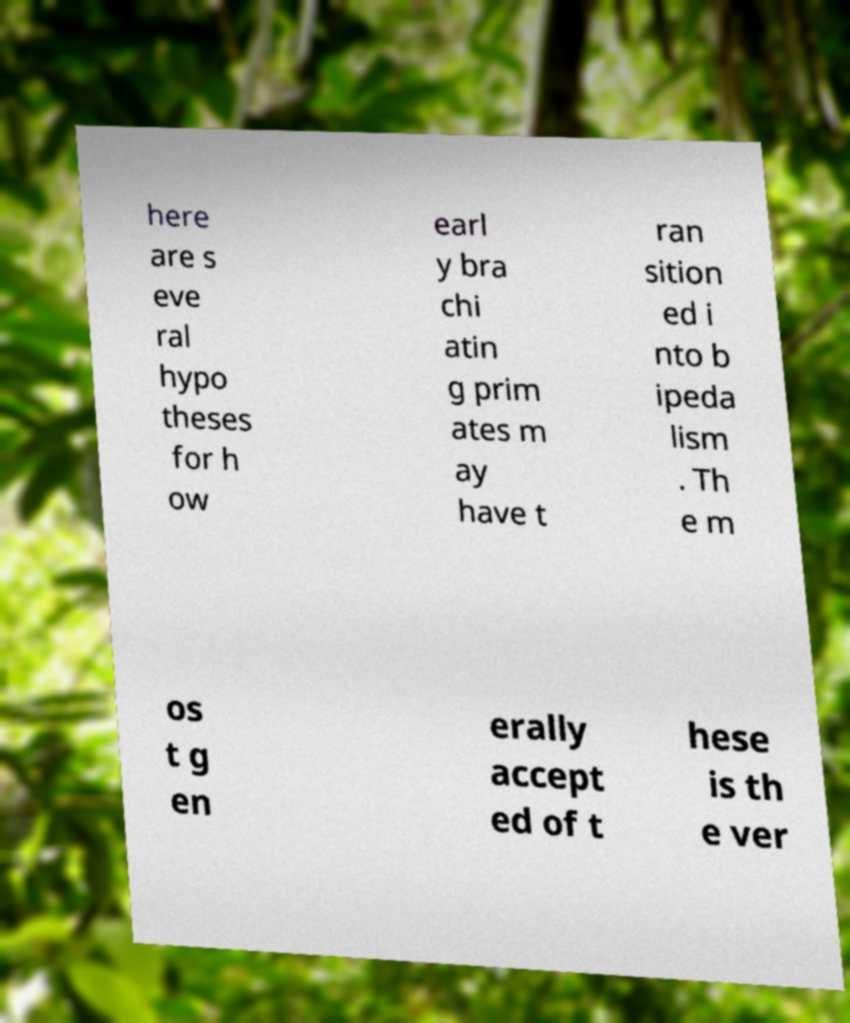What messages or text are displayed in this image? I need them in a readable, typed format. here are s eve ral hypo theses for h ow earl y bra chi atin g prim ates m ay have t ran sition ed i nto b ipeda lism . Th e m os t g en erally accept ed of t hese is th e ver 